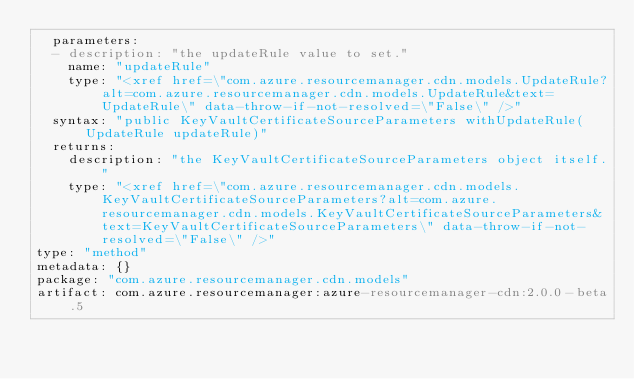Convert code to text. <code><loc_0><loc_0><loc_500><loc_500><_YAML_>  parameters:
  - description: "the updateRule value to set."
    name: "updateRule"
    type: "<xref href=\"com.azure.resourcemanager.cdn.models.UpdateRule?alt=com.azure.resourcemanager.cdn.models.UpdateRule&text=UpdateRule\" data-throw-if-not-resolved=\"False\" />"
  syntax: "public KeyVaultCertificateSourceParameters withUpdateRule(UpdateRule updateRule)"
  returns:
    description: "the KeyVaultCertificateSourceParameters object itself."
    type: "<xref href=\"com.azure.resourcemanager.cdn.models.KeyVaultCertificateSourceParameters?alt=com.azure.resourcemanager.cdn.models.KeyVaultCertificateSourceParameters&text=KeyVaultCertificateSourceParameters\" data-throw-if-not-resolved=\"False\" />"
type: "method"
metadata: {}
package: "com.azure.resourcemanager.cdn.models"
artifact: com.azure.resourcemanager:azure-resourcemanager-cdn:2.0.0-beta.5
</code> 